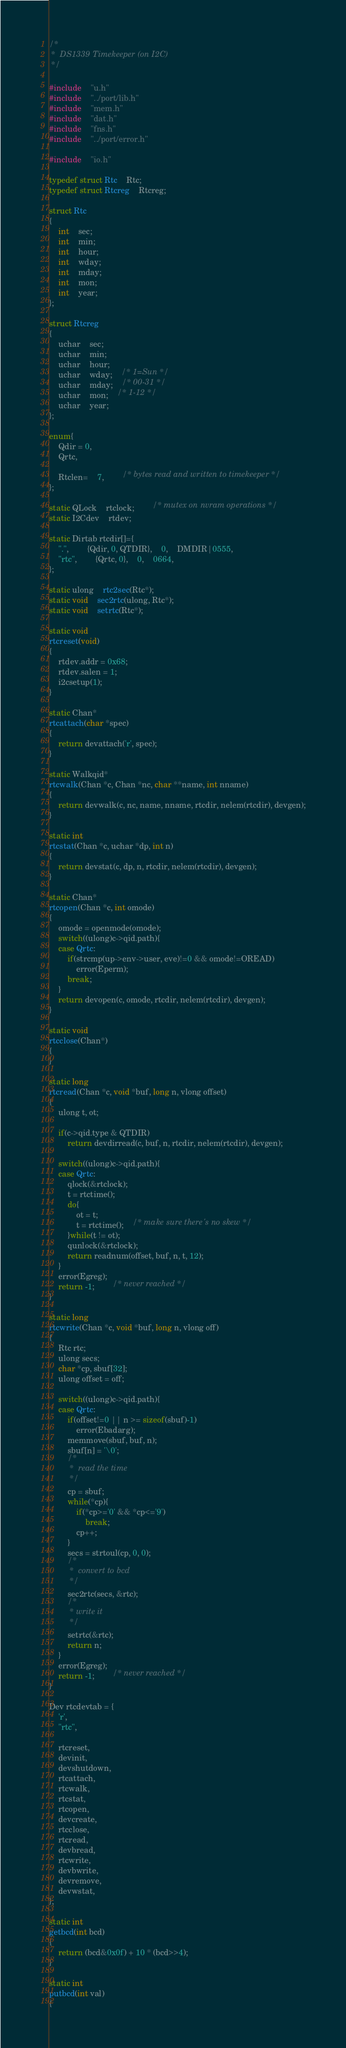<code> <loc_0><loc_0><loc_500><loc_500><_C_>/*
 *	DS1339 Timekeeper (on I2C)
 */

#include	"u.h"
#include	"../port/lib.h"
#include	"mem.h"
#include	"dat.h"
#include	"fns.h"
#include	"../port/error.h"

#include	"io.h"

typedef struct Rtc	Rtc;
typedef struct Rtcreg	Rtcreg;

struct Rtc
{
	int	sec;
	int	min;
	int	hour;
	int	wday;
	int	mday;
	int	mon;
	int	year;
};

struct Rtcreg
{
	uchar	sec;
	uchar	min;
	uchar	hour;
	uchar	wday;	/* 1=Sun */
	uchar	mday;	/* 00-31 */
	uchar	mon;	/* 1-12 */
	uchar	year;
};

enum{
	Qdir = 0,
	Qrtc,

	Rtclen=	7,		/* bytes read and written to timekeeper */
};

static QLock	rtclock;		/* mutex on nvram operations */
static I2Cdev	rtdev;

static Dirtab rtcdir[]={
	".",		{Qdir, 0, QTDIR},	0,	DMDIR|0555,
	"rtc",		{Qrtc, 0},	0,	0664,
};

static ulong	rtc2sec(Rtc*);
static void	sec2rtc(ulong, Rtc*);
static void	setrtc(Rtc*);

static void
rtcreset(void)
{
	rtdev.addr = 0x68;
	rtdev.salen = 1;
	i2csetup(1);
}

static Chan*
rtcattach(char *spec)
{
	return devattach('r', spec);
}

static Walkqid*
rtcwalk(Chan *c, Chan *nc, char **name, int nname)
{
	return devwalk(c, nc, name, nname, rtcdir, nelem(rtcdir), devgen);
}

static int	 
rtcstat(Chan *c, uchar *dp, int n)
{
	return devstat(c, dp, n, rtcdir, nelem(rtcdir), devgen);
}

static Chan*
rtcopen(Chan *c, int omode)
{
	omode = openmode(omode);
	switch((ulong)c->qid.path){
	case Qrtc:
		if(strcmp(up->env->user, eve)!=0 && omode!=OREAD)
			error(Eperm);
		break;
	}
	return devopen(c, omode, rtcdir, nelem(rtcdir), devgen);
}

static void	 
rtcclose(Chan*)
{
}

static long	 
rtcread(Chan *c, void *buf, long n, vlong offset)
{
	ulong t, ot;

	if(c->qid.type & QTDIR)
		return devdirread(c, buf, n, rtcdir, nelem(rtcdir), devgen);

	switch((ulong)c->qid.path){
	case Qrtc:
		qlock(&rtclock);
		t = rtctime();
		do{
			ot = t;
			t = rtctime();	/* make sure there's no skew */
		}while(t != ot);
		qunlock(&rtclock);
		return readnum(offset, buf, n, t, 12);
	}
	error(Egreg);
	return -1;		/* never reached */
}

static long	 
rtcwrite(Chan *c, void *buf, long n, vlong off)
{
	Rtc rtc;
	ulong secs;
	char *cp, sbuf[32];
	ulong offset = off;

	switch((ulong)c->qid.path){
	case Qrtc:
		if(offset!=0 || n >= sizeof(sbuf)-1)
			error(Ebadarg);
		memmove(sbuf, buf, n);
		sbuf[n] = '\0';
		/*
		 *  read the time
		 */
		cp = sbuf;
		while(*cp){
			if(*cp>='0' && *cp<='9')
				break;
			cp++;
		}
		secs = strtoul(cp, 0, 0);
		/*
		 *  convert to bcd
		 */
		sec2rtc(secs, &rtc);
		/*
		 * write it
		 */
		setrtc(&rtc);
		return n;
	}
	error(Egreg);
	return -1;		/* never reached */
}

Dev rtcdevtab = {
	'r',
	"rtc",

	rtcreset,
	devinit,
	devshutdown,
	rtcattach,
	rtcwalk,
	rtcstat,
	rtcopen,
	devcreate,
	rtcclose,
	rtcread,
	devbread,
	rtcwrite,
	devbwrite,
	devremove,
	devwstat,
};

static int
getbcd(int bcd)
{
	return (bcd&0x0f) + 10 * (bcd>>4);
}

static int
putbcd(int val)
{</code> 